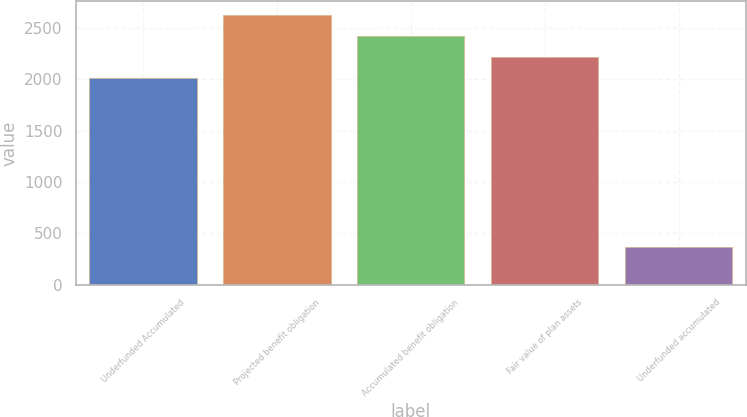Convert chart to OTSL. <chart><loc_0><loc_0><loc_500><loc_500><bar_chart><fcel>Underfunded Accumulated<fcel>Projected benefit obligation<fcel>Accumulated benefit obligation<fcel>Fair value of plan assets<fcel>Underfunded accumulated<nl><fcel>2009<fcel>2629.4<fcel>2422.6<fcel>2215.8<fcel>363<nl></chart> 